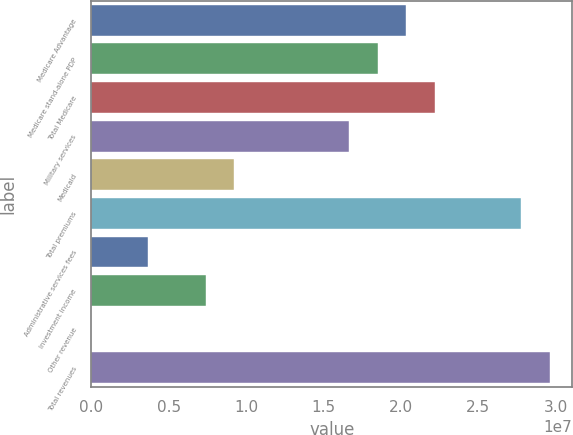Convert chart. <chart><loc_0><loc_0><loc_500><loc_500><bar_chart><fcel>Medicare Advantage<fcel>Medicare stand-alone PDP<fcel>Total Medicare<fcel>Military services<fcel>Medicaid<fcel>Total premiums<fcel>Administrative services fees<fcel>Investment income<fcel>Other revenue<fcel>Total revenues<nl><fcel>2.03446e+07<fcel>1.84952e+07<fcel>2.21939e+07<fcel>1.66459e+07<fcel>9.24846e+06<fcel>2.7742e+07<fcel>3.70041e+06<fcel>7.39911e+06<fcel>1705<fcel>2.95913e+07<nl></chart> 